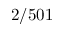Convert formula to latex. <formula><loc_0><loc_0><loc_500><loc_500>2 / 5 0 1</formula> 